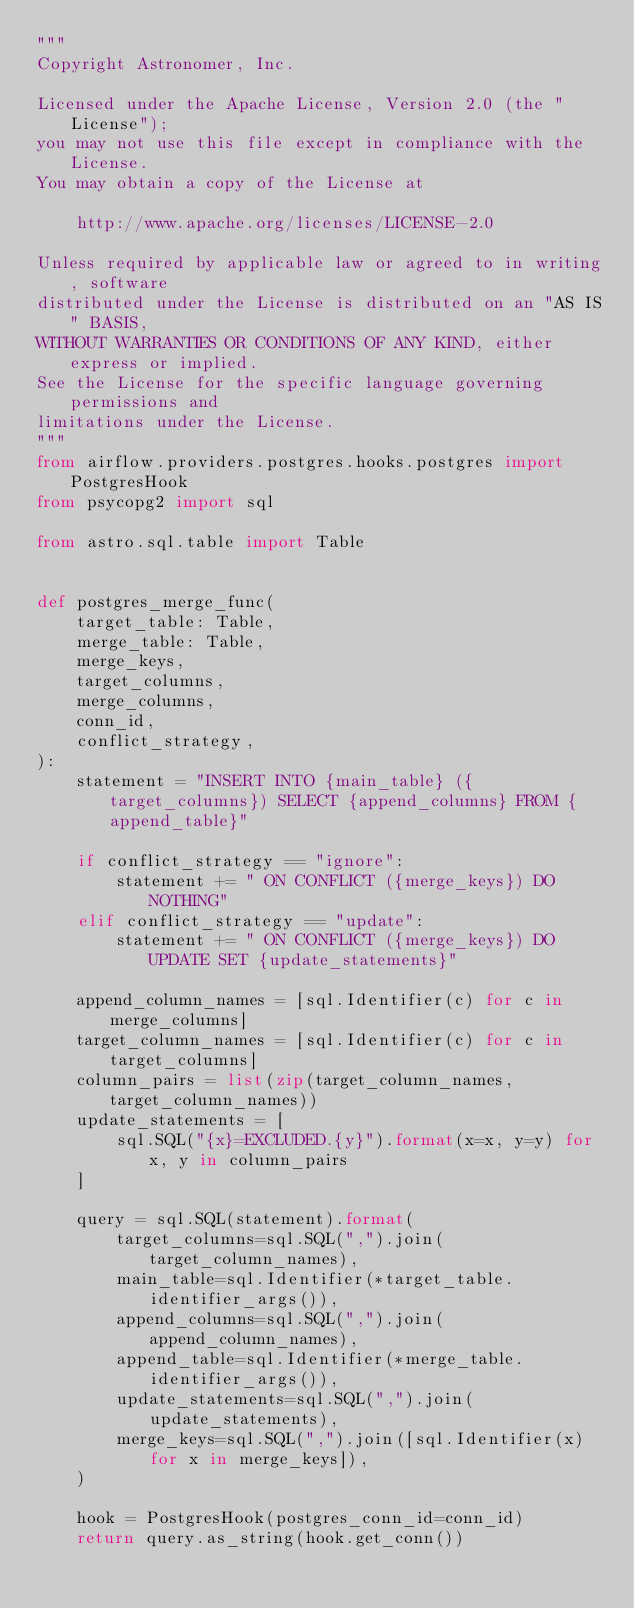<code> <loc_0><loc_0><loc_500><loc_500><_Python_>"""
Copyright Astronomer, Inc.

Licensed under the Apache License, Version 2.0 (the "License");
you may not use this file except in compliance with the License.
You may obtain a copy of the License at

    http://www.apache.org/licenses/LICENSE-2.0

Unless required by applicable law or agreed to in writing, software
distributed under the License is distributed on an "AS IS" BASIS,
WITHOUT WARRANTIES OR CONDITIONS OF ANY KIND, either express or implied.
See the License for the specific language governing permissions and
limitations under the License.
"""
from airflow.providers.postgres.hooks.postgres import PostgresHook
from psycopg2 import sql

from astro.sql.table import Table


def postgres_merge_func(
    target_table: Table,
    merge_table: Table,
    merge_keys,
    target_columns,
    merge_columns,
    conn_id,
    conflict_strategy,
):
    statement = "INSERT INTO {main_table} ({target_columns}) SELECT {append_columns} FROM {append_table}"

    if conflict_strategy == "ignore":
        statement += " ON CONFLICT ({merge_keys}) DO NOTHING"
    elif conflict_strategy == "update":
        statement += " ON CONFLICT ({merge_keys}) DO UPDATE SET {update_statements}"

    append_column_names = [sql.Identifier(c) for c in merge_columns]
    target_column_names = [sql.Identifier(c) for c in target_columns]
    column_pairs = list(zip(target_column_names, target_column_names))
    update_statements = [
        sql.SQL("{x}=EXCLUDED.{y}").format(x=x, y=y) for x, y in column_pairs
    ]

    query = sql.SQL(statement).format(
        target_columns=sql.SQL(",").join(target_column_names),
        main_table=sql.Identifier(*target_table.identifier_args()),
        append_columns=sql.SQL(",").join(append_column_names),
        append_table=sql.Identifier(*merge_table.identifier_args()),
        update_statements=sql.SQL(",").join(update_statements),
        merge_keys=sql.SQL(",").join([sql.Identifier(x) for x in merge_keys]),
    )

    hook = PostgresHook(postgres_conn_id=conn_id)
    return query.as_string(hook.get_conn())
</code> 